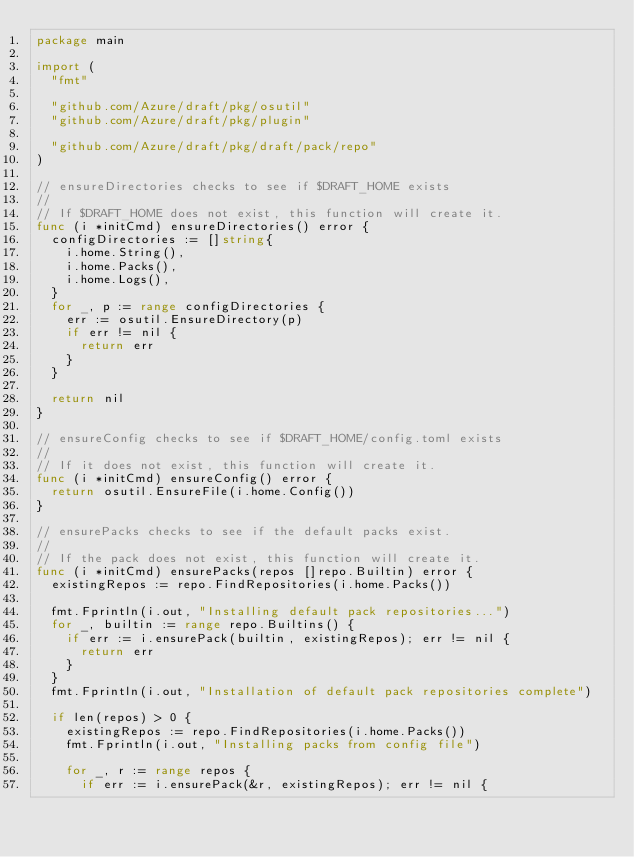Convert code to text. <code><loc_0><loc_0><loc_500><loc_500><_Go_>package main

import (
	"fmt"

	"github.com/Azure/draft/pkg/osutil"
	"github.com/Azure/draft/pkg/plugin"

	"github.com/Azure/draft/pkg/draft/pack/repo"
)

// ensureDirectories checks to see if $DRAFT_HOME exists
//
// If $DRAFT_HOME does not exist, this function will create it.
func (i *initCmd) ensureDirectories() error {
	configDirectories := []string{
		i.home.String(),
		i.home.Packs(),
		i.home.Logs(),
	}
	for _, p := range configDirectories {
		err := osutil.EnsureDirectory(p)
		if err != nil {
			return err
		}
	}

	return nil
}

// ensureConfig checks to see if $DRAFT_HOME/config.toml exists
//
// If it does not exist, this function will create it.
func (i *initCmd) ensureConfig() error {
	return osutil.EnsureFile(i.home.Config())
}

// ensurePacks checks to see if the default packs exist.
//
// If the pack does not exist, this function will create it.
func (i *initCmd) ensurePacks(repos []repo.Builtin) error {
	existingRepos := repo.FindRepositories(i.home.Packs())

	fmt.Fprintln(i.out, "Installing default pack repositories...")
	for _, builtin := range repo.Builtins() {
		if err := i.ensurePack(builtin, existingRepos); err != nil {
			return err
		}
	}
	fmt.Fprintln(i.out, "Installation of default pack repositories complete")

	if len(repos) > 0 {
		existingRepos := repo.FindRepositories(i.home.Packs())
		fmt.Fprintln(i.out, "Installing packs from config file")

		for _, r := range repos {
			if err := i.ensurePack(&r, existingRepos); err != nil {</code> 